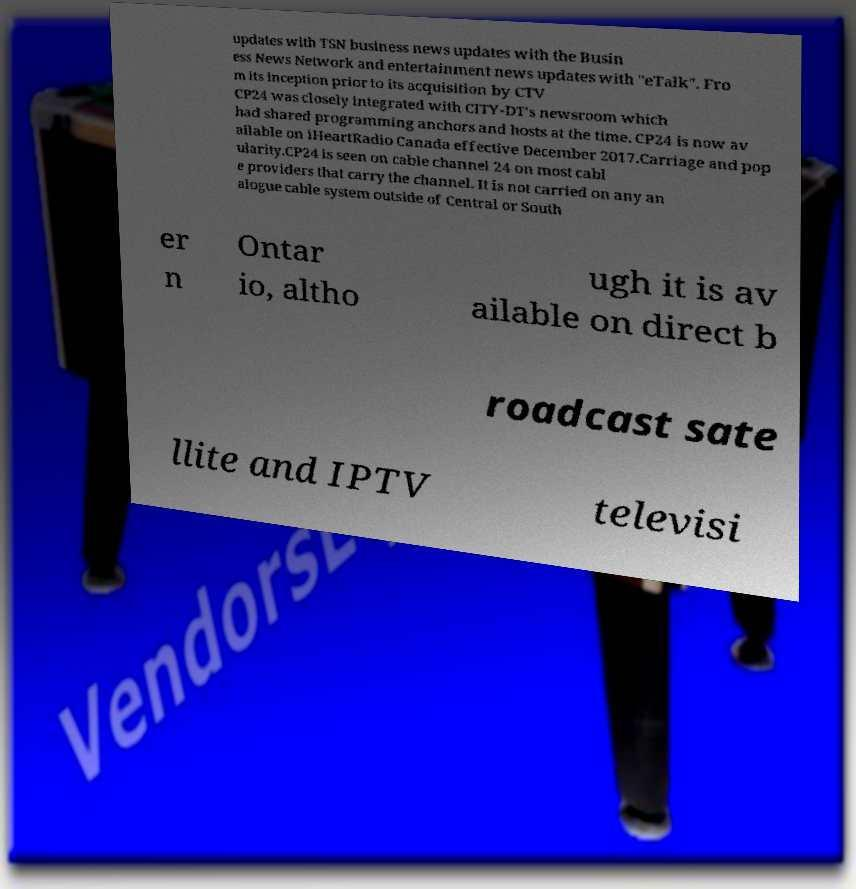Could you extract and type out the text from this image? updates with TSN business news updates with the Busin ess News Network and entertainment news updates with "eTalk". Fro m its inception prior to its acquisition by CTV CP24 was closely integrated with CITY-DT's newsroom which had shared programming anchors and hosts at the time. CP24 is now av ailable on iHeartRadio Canada effective December 2017.Carriage and pop ularity.CP24 is seen on cable channel 24 on most cabl e providers that carry the channel. It is not carried on any an alogue cable system outside of Central or South er n Ontar io, altho ugh it is av ailable on direct b roadcast sate llite and IPTV televisi 